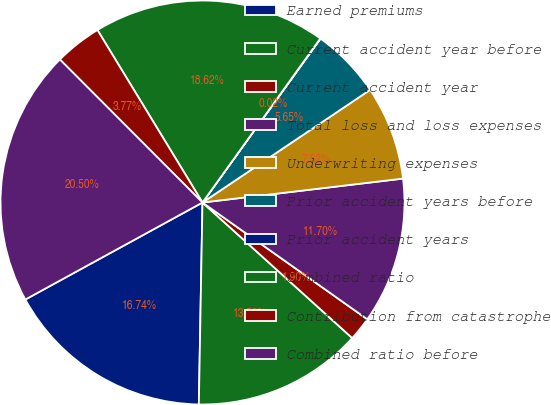<chart> <loc_0><loc_0><loc_500><loc_500><pie_chart><fcel>Earned premiums<fcel>Current accident year before<fcel>Current accident year<fcel>Total loss and loss expenses<fcel>Underwriting expenses<fcel>Prior accident years before<fcel>Prior accident years<fcel>Combined ratio<fcel>Contribution from catastrophe<fcel>Combined ratio before<nl><fcel>16.74%<fcel>13.58%<fcel>1.9%<fcel>11.7%<fcel>7.53%<fcel>5.65%<fcel>0.02%<fcel>18.62%<fcel>3.77%<fcel>20.5%<nl></chart> 